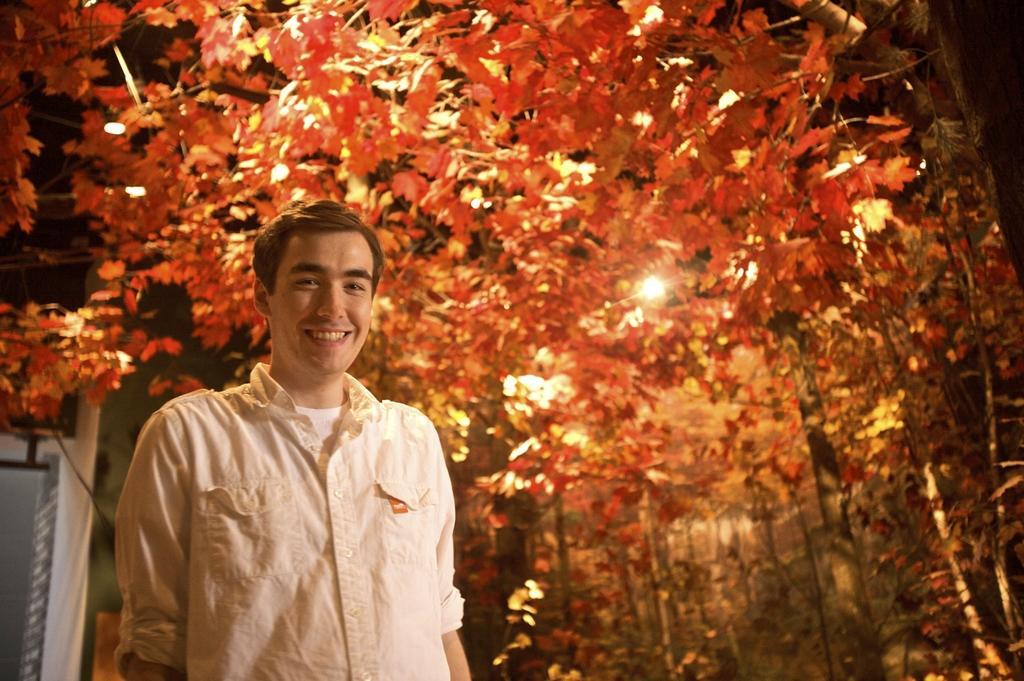In one or two sentences, can you explain what this image depicts? In the image in the center, we can see one person standing and he is smiling. In the background, we can see trees, one pole and light. 